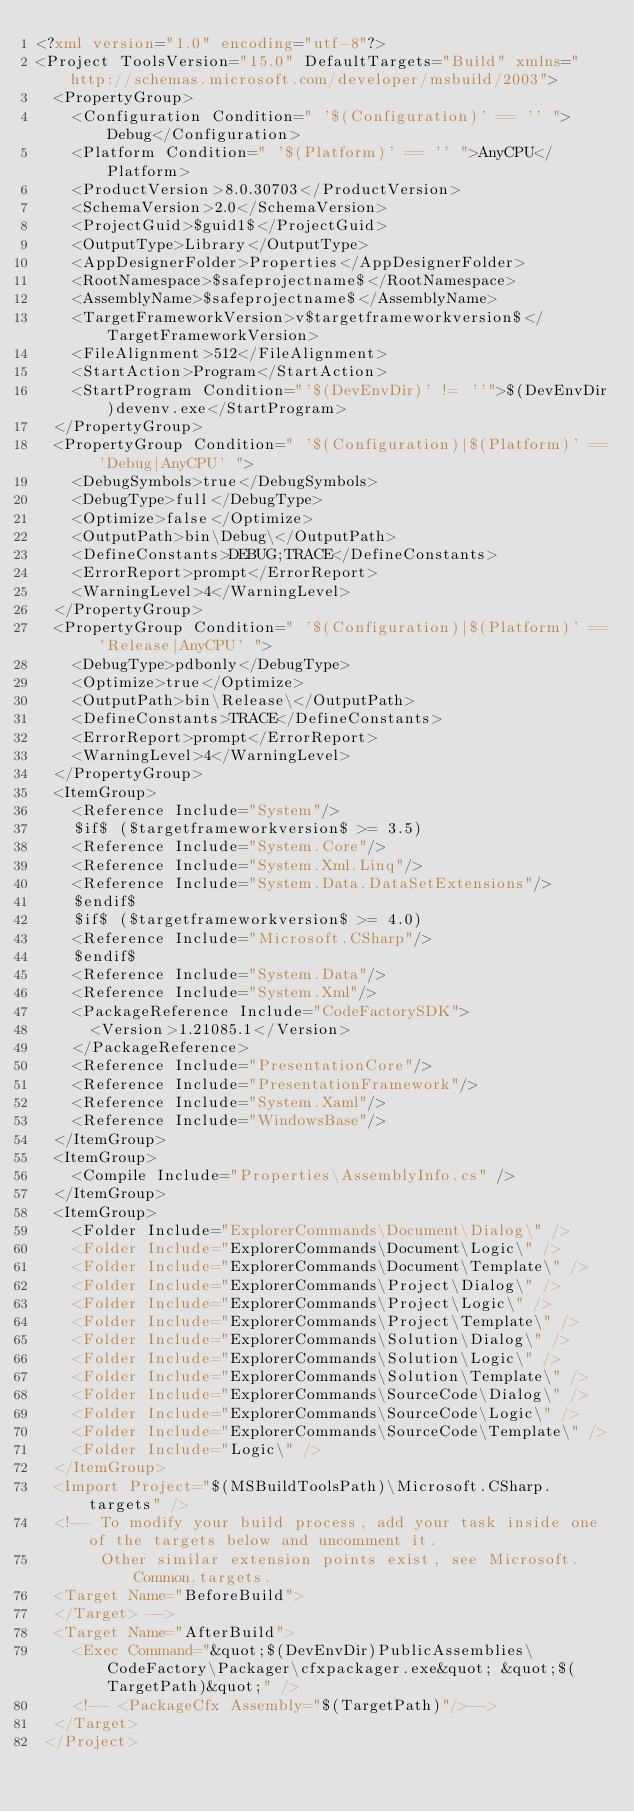Convert code to text. <code><loc_0><loc_0><loc_500><loc_500><_XML_><?xml version="1.0" encoding="utf-8"?>
<Project ToolsVersion="15.0" DefaultTargets="Build" xmlns="http://schemas.microsoft.com/developer/msbuild/2003">
	<PropertyGroup>
		<Configuration Condition=" '$(Configuration)' == '' ">Debug</Configuration>
		<Platform Condition=" '$(Platform)' == '' ">AnyCPU</Platform>
		<ProductVersion>8.0.30703</ProductVersion>
		<SchemaVersion>2.0</SchemaVersion>
		<ProjectGuid>$guid1$</ProjectGuid>
		<OutputType>Library</OutputType>
		<AppDesignerFolder>Properties</AppDesignerFolder>
		<RootNamespace>$safeprojectname$</RootNamespace>
		<AssemblyName>$safeprojectname$</AssemblyName>
		<TargetFrameworkVersion>v$targetframeworkversion$</TargetFrameworkVersion>
		<FileAlignment>512</FileAlignment>
    <StartAction>Program</StartAction>
    <StartProgram Condition="'$(DevEnvDir)' != ''">$(DevEnvDir)devenv.exe</StartProgram>
	</PropertyGroup>
	<PropertyGroup Condition=" '$(Configuration)|$(Platform)' == 'Debug|AnyCPU' ">
		<DebugSymbols>true</DebugSymbols>
		<DebugType>full</DebugType>
		<Optimize>false</Optimize>
		<OutputPath>bin\Debug\</OutputPath>
		<DefineConstants>DEBUG;TRACE</DefineConstants>
		<ErrorReport>prompt</ErrorReport>
		<WarningLevel>4</WarningLevel>
	</PropertyGroup>
	<PropertyGroup Condition=" '$(Configuration)|$(Platform)' == 'Release|AnyCPU' ">
		<DebugType>pdbonly</DebugType>
 		<Optimize>true</Optimize>
		<OutputPath>bin\Release\</OutputPath>
		<DefineConstants>TRACE</DefineConstants>
		<ErrorReport>prompt</ErrorReport>
		<WarningLevel>4</WarningLevel>
	</PropertyGroup>
	<ItemGroup>
		<Reference Include="System"/>
		$if$ ($targetframeworkversion$ >= 3.5)
		<Reference Include="System.Core"/>
		<Reference Include="System.Xml.Linq"/>
		<Reference Include="System.Data.DataSetExtensions"/>
		$endif$
		$if$ ($targetframeworkversion$ >= 4.0)
		<Reference Include="Microsoft.CSharp"/>
 		$endif$
		<Reference Include="System.Data"/>
		<Reference Include="System.Xml"/>
    <PackageReference Include="CodeFactorySDK">
      <Version>1.21085.1</Version>
    </PackageReference>
    <Reference Include="PresentationCore"/>
    <Reference Include="PresentationFramework"/>
    <Reference Include="System.Xaml"/>
    <Reference Include="WindowsBase"/>
	</ItemGroup>
	<ItemGroup>
    <Compile Include="Properties\AssemblyInfo.cs" />
	</ItemGroup>
  <ItemGroup>
    <Folder Include="ExplorerCommands\Document\Dialog\" />
    <Folder Include="ExplorerCommands\Document\Logic\" />
    <Folder Include="ExplorerCommands\Document\Template\" />
    <Folder Include="ExplorerCommands\Project\Dialog\" />
    <Folder Include="ExplorerCommands\Project\Logic\" />
    <Folder Include="ExplorerCommands\Project\Template\" />
    <Folder Include="ExplorerCommands\Solution\Dialog\" />
    <Folder Include="ExplorerCommands\Solution\Logic\" />
    <Folder Include="ExplorerCommands\Solution\Template\" />
    <Folder Include="ExplorerCommands\SourceCode\Dialog\" />
    <Folder Include="ExplorerCommands\SourceCode\Logic\" />
    <Folder Include="ExplorerCommands\SourceCode\Template\" />
    <Folder Include="Logic\" />
  </ItemGroup>
	<Import Project="$(MSBuildToolsPath)\Microsoft.CSharp.targets" />
  <!-- To modify your build process, add your task inside one of the targets below and uncomment it. 
       Other similar extension points exist, see Microsoft.Common.targets.
  <Target Name="BeforeBuild">
  </Target> -->
  <Target Name="AfterBuild">
    <Exec Command="&quot;$(DevEnvDir)PublicAssemblies\CodeFactory\Packager\cfxpackager.exe&quot; &quot;$(TargetPath)&quot;" />
    <!-- <PackageCfx Assembly="$(TargetPath)"/>-->
  </Target>
 </Project>
</code> 